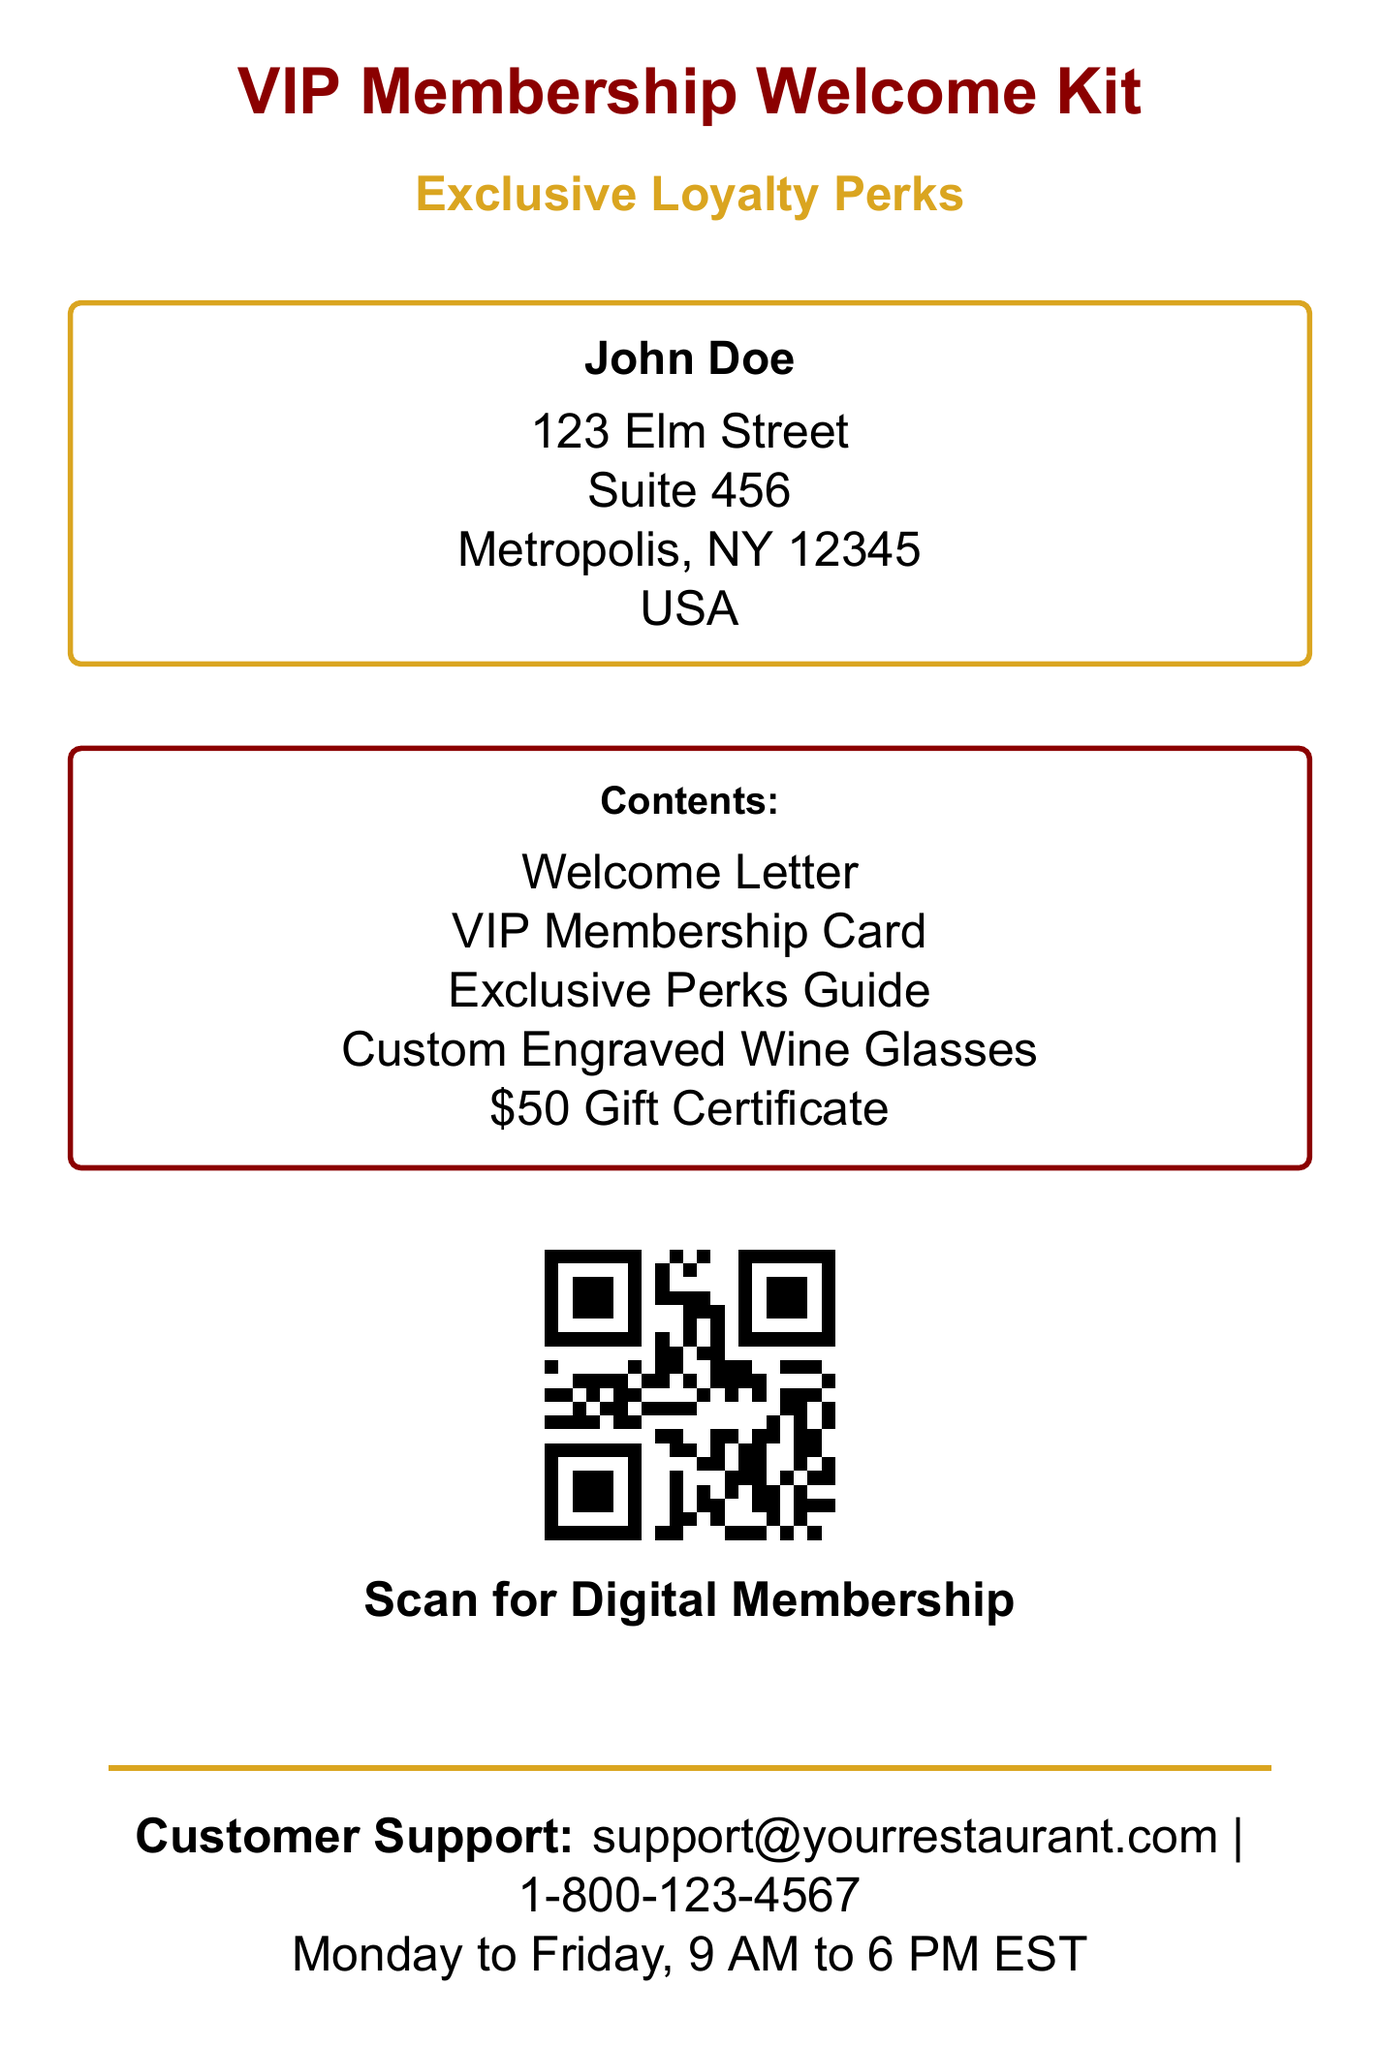What is the recipient's name? The recipient's name is prominently displayed at the top of the document.
Answer: John Doe What is the address of the recipient? The full address is listed in a box within the document.
Answer: 123 Elm Street, Suite 456, Metropolis, NY 12345, USA What are the items included in the welcome kit? The items are clearly outlined in a distinct section of the document.
Answer: Welcome Letter, VIP Membership Card, Exclusive Perks Guide, Custom Engraved Wine Glasses, $50 Gift Certificate What is the QR code for? The QR code in the document serves a specific purpose related to the membership.
Answer: Scan for Digital Membership What is the customer support email address? The email address is located in the customer support section at the bottom of the document.
Answer: support@yourrestaurant.com What is the color scheme used for the document title? The document title uses a specific color combination that can be identified easily.
Answer: Restaurant red What does the bold line at the bottom of the page represent? The bold line exhibits a specific feature intended for emphasis in the document.
Answer: Separator What day and time is customer support available? The availability of customer support is explicitly mentioned in the contact section.
Answer: Monday to Friday, 9 AM to 6 PM EST 